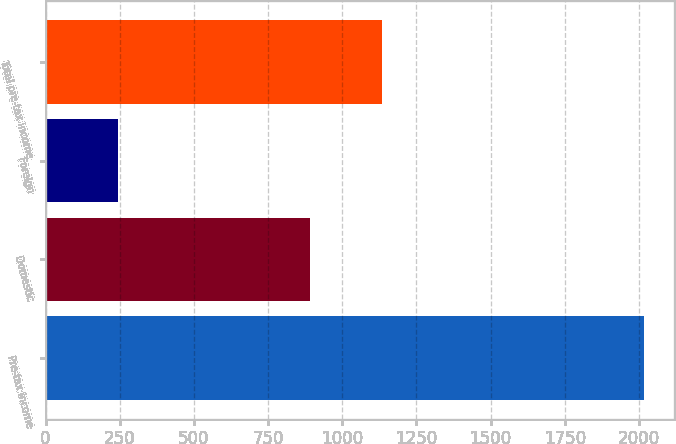<chart> <loc_0><loc_0><loc_500><loc_500><bar_chart><fcel>Pre-tax income<fcel>Domestic<fcel>Foreign<fcel>Total pre-tax income<nl><fcel>2017<fcel>891.8<fcel>243.1<fcel>1134.9<nl></chart> 